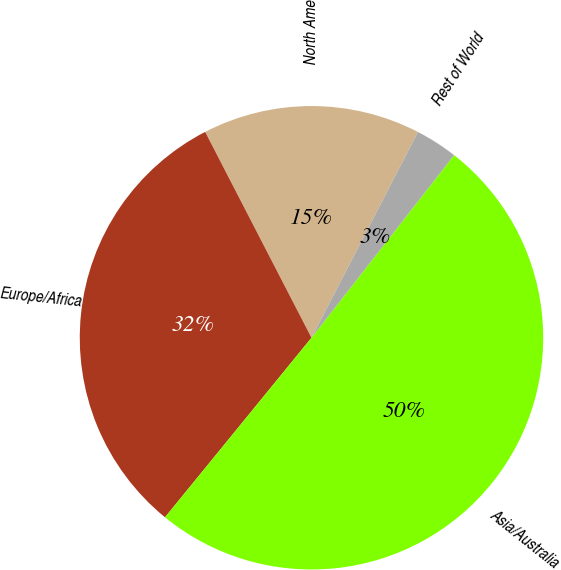Convert chart to OTSL. <chart><loc_0><loc_0><loc_500><loc_500><pie_chart><fcel>North America<fcel>Europe/Africa<fcel>Asia/Australia<fcel>Rest of World<nl><fcel>15.19%<fcel>31.52%<fcel>50.34%<fcel>2.95%<nl></chart> 